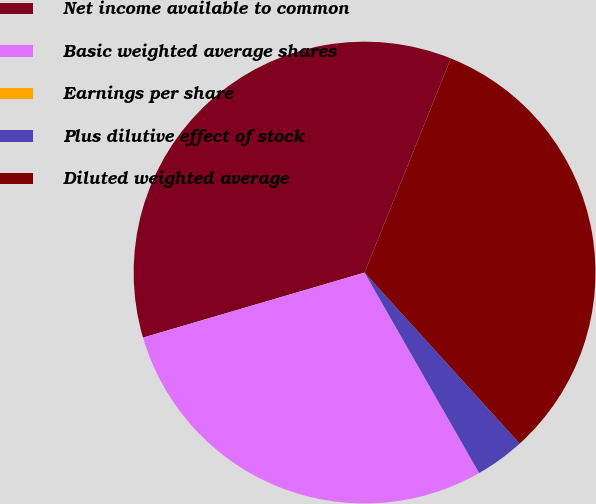<chart> <loc_0><loc_0><loc_500><loc_500><pie_chart><fcel>Net income available to common<fcel>Basic weighted average shares<fcel>Earnings per share<fcel>Plus dilutive effect of stock<fcel>Diluted weighted average<nl><fcel>35.64%<fcel>28.72%<fcel>0.0%<fcel>3.46%<fcel>32.18%<nl></chart> 